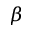Convert formula to latex. <formula><loc_0><loc_0><loc_500><loc_500>\beta</formula> 